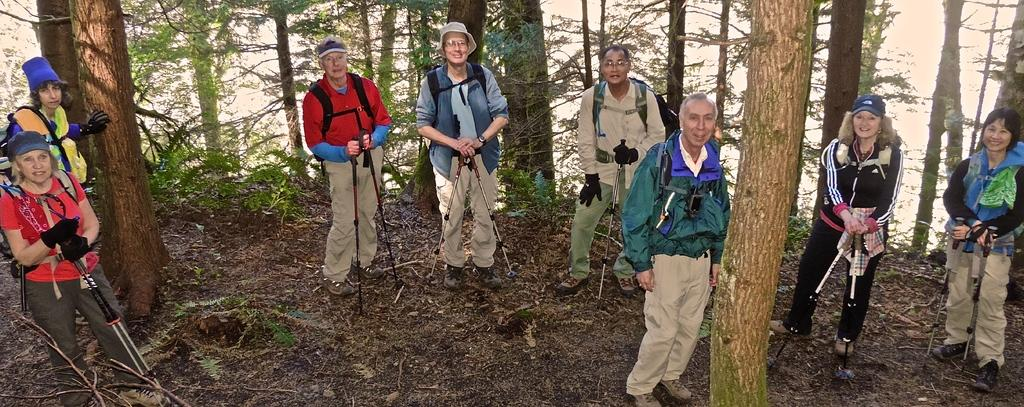What is the main subject of the image? The main subject of the image is many people standing on the ground. What can be seen in the background of the image? There are many trees around in the image. What type of turkey can be seen walking along the seashore in the image? There is no turkey or seashore present in the image; it features many people standing on the ground with many trees around. 